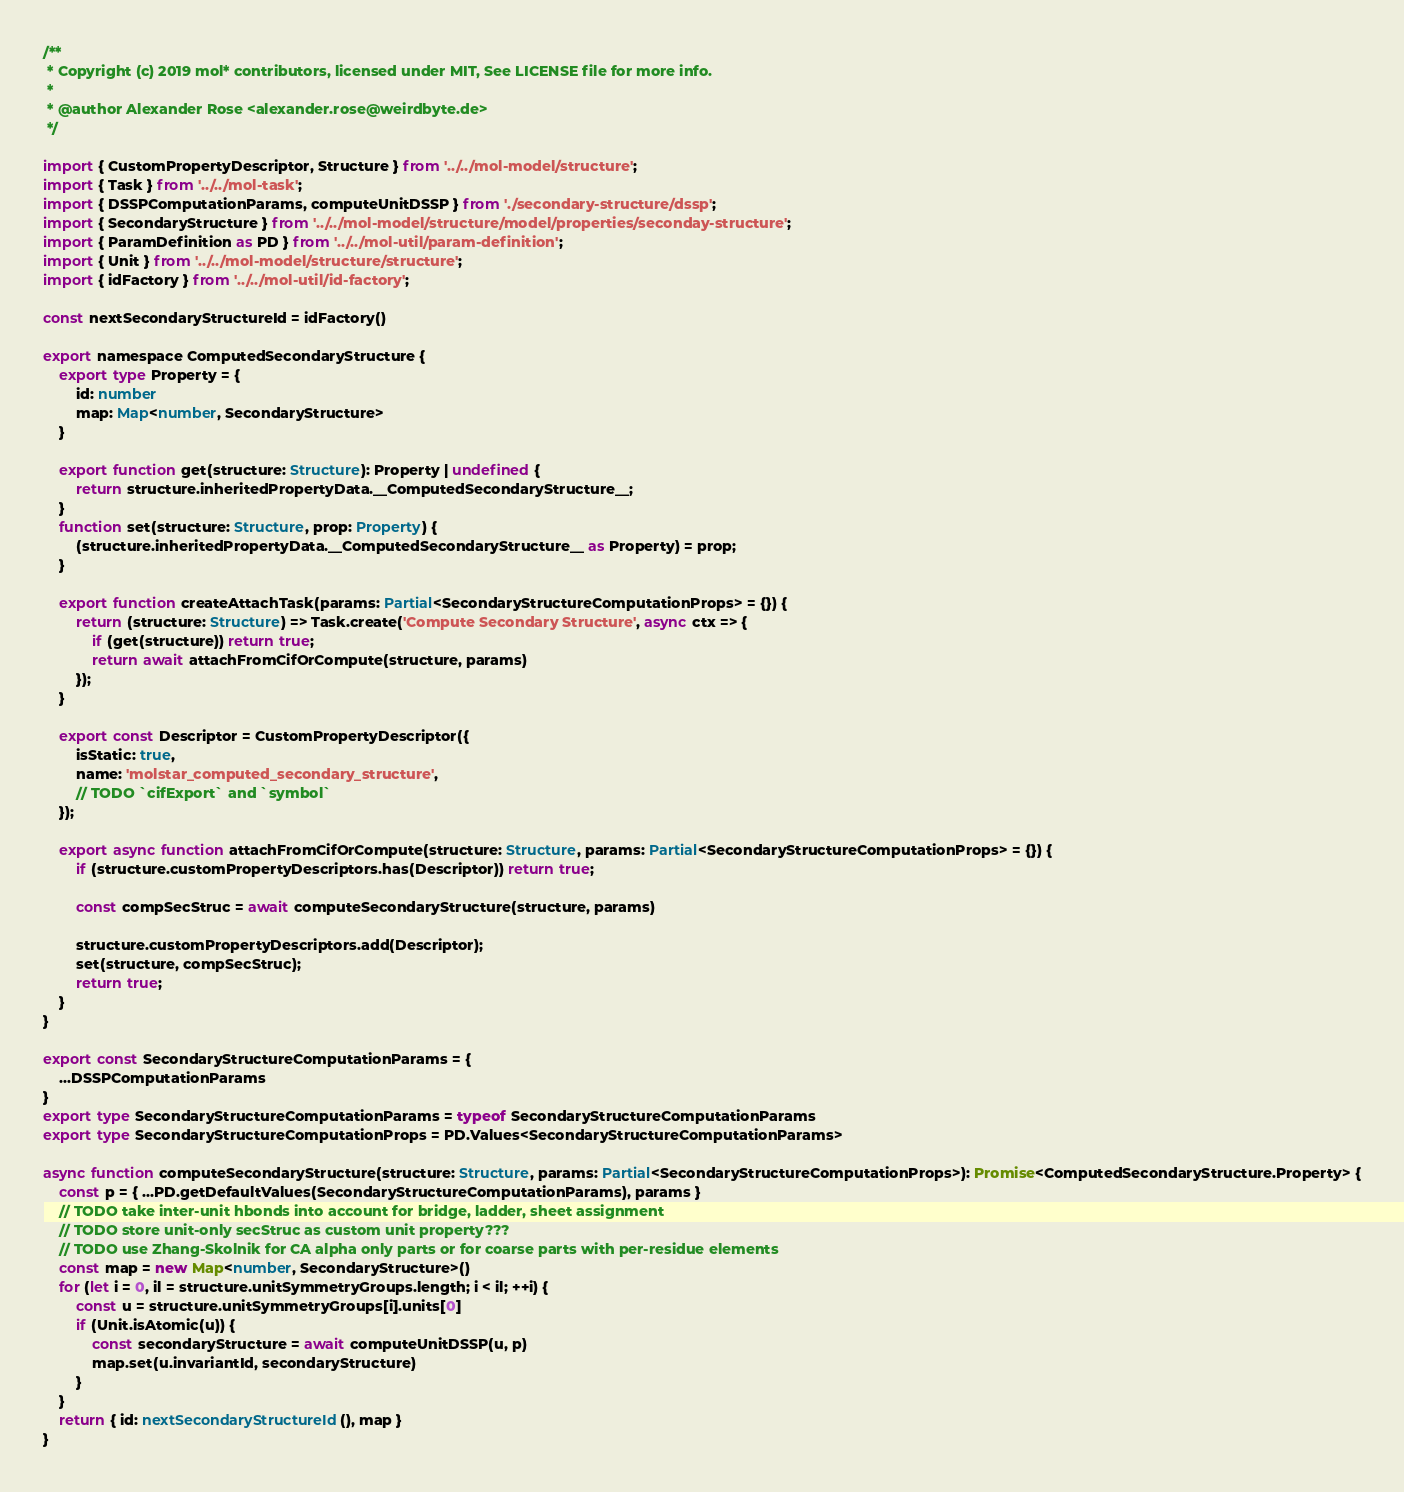<code> <loc_0><loc_0><loc_500><loc_500><_TypeScript_>/**
 * Copyright (c) 2019 mol* contributors, licensed under MIT, See LICENSE file for more info.
 *
 * @author Alexander Rose <alexander.rose@weirdbyte.de>
 */

import { CustomPropertyDescriptor, Structure } from '../../mol-model/structure';
import { Task } from '../../mol-task';
import { DSSPComputationParams, computeUnitDSSP } from './secondary-structure/dssp';
import { SecondaryStructure } from '../../mol-model/structure/model/properties/seconday-structure';
import { ParamDefinition as PD } from '../../mol-util/param-definition';
import { Unit } from '../../mol-model/structure/structure';
import { idFactory } from '../../mol-util/id-factory';

const nextSecondaryStructureId = idFactory()

export namespace ComputedSecondaryStructure {
    export type Property = {
        id: number
        map: Map<number, SecondaryStructure>
    }

    export function get(structure: Structure): Property | undefined {
        return structure.inheritedPropertyData.__ComputedSecondaryStructure__;
    }
    function set(structure: Structure, prop: Property) {
        (structure.inheritedPropertyData.__ComputedSecondaryStructure__ as Property) = prop;
    }

    export function createAttachTask(params: Partial<SecondaryStructureComputationProps> = {}) {
        return (structure: Structure) => Task.create('Compute Secondary Structure', async ctx => {
            if (get(structure)) return true;
            return await attachFromCifOrCompute(structure, params)
        });
    }

    export const Descriptor = CustomPropertyDescriptor({
        isStatic: true,
        name: 'molstar_computed_secondary_structure',
        // TODO `cifExport` and `symbol`
    });

    export async function attachFromCifOrCompute(structure: Structure, params: Partial<SecondaryStructureComputationProps> = {}) {
        if (structure.customPropertyDescriptors.has(Descriptor)) return true;

        const compSecStruc = await computeSecondaryStructure(structure, params)

        structure.customPropertyDescriptors.add(Descriptor);
        set(structure, compSecStruc);
        return true;
    }
}

export const SecondaryStructureComputationParams = {
    ...DSSPComputationParams
}
export type SecondaryStructureComputationParams = typeof SecondaryStructureComputationParams
export type SecondaryStructureComputationProps = PD.Values<SecondaryStructureComputationParams>

async function computeSecondaryStructure(structure: Structure, params: Partial<SecondaryStructureComputationProps>): Promise<ComputedSecondaryStructure.Property> {
    const p = { ...PD.getDefaultValues(SecondaryStructureComputationParams), params }
    // TODO take inter-unit hbonds into account for bridge, ladder, sheet assignment
    // TODO store unit-only secStruc as custom unit property???
    // TODO use Zhang-Skolnik for CA alpha only parts or for coarse parts with per-residue elements
    const map = new Map<number, SecondaryStructure>()
    for (let i = 0, il = structure.unitSymmetryGroups.length; i < il; ++i) {
        const u = structure.unitSymmetryGroups[i].units[0]
        if (Unit.isAtomic(u)) {
            const secondaryStructure = await computeUnitDSSP(u, p)
            map.set(u.invariantId, secondaryStructure)
        }
    }
    return { id: nextSecondaryStructureId(), map }
}</code> 